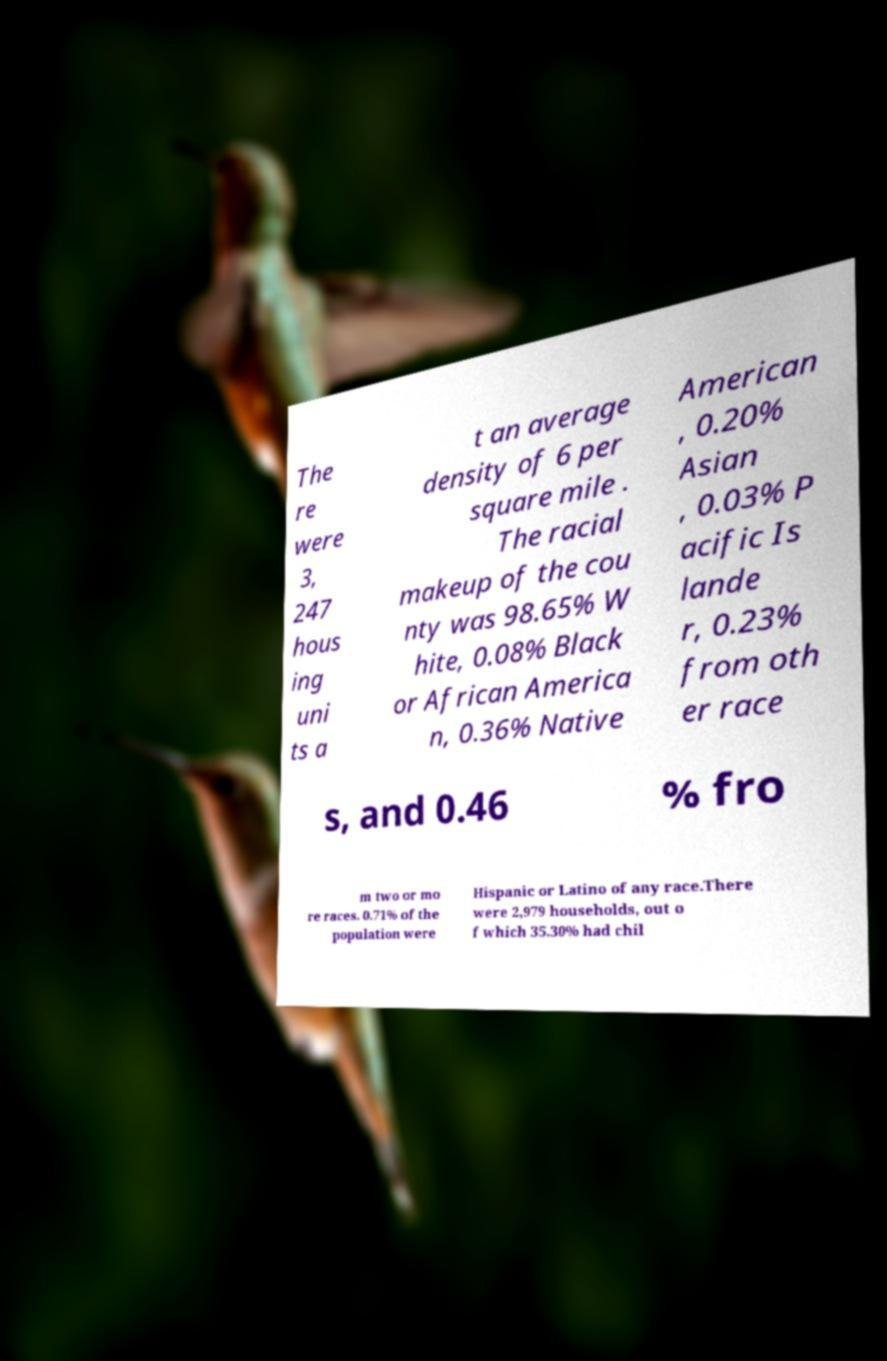For documentation purposes, I need the text within this image transcribed. Could you provide that? The re were 3, 247 hous ing uni ts a t an average density of 6 per square mile . The racial makeup of the cou nty was 98.65% W hite, 0.08% Black or African America n, 0.36% Native American , 0.20% Asian , 0.03% P acific Is lande r, 0.23% from oth er race s, and 0.46 % fro m two or mo re races. 0.71% of the population were Hispanic or Latino of any race.There were 2,979 households, out o f which 35.30% had chil 